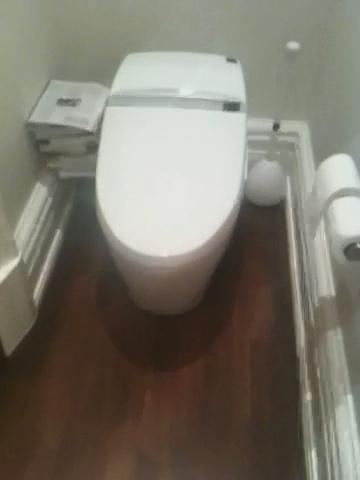Question: what is on the wall?
Choices:
A. Wallpaper.
B. Writing.
C. Toilet paper.
D. Newspaper.
Answer with the letter. Answer: C Question: how is the toilet positioned?
Choices:
A. To the left.
B. To the right.
C. Next to the sink.
D. Centered.
Answer with the letter. Answer: D Question: why is the toilet brush used?
Choices:
A. Scrub.
B. To clean.
C. To shine.
D. To polish.
Answer with the letter. Answer: B 